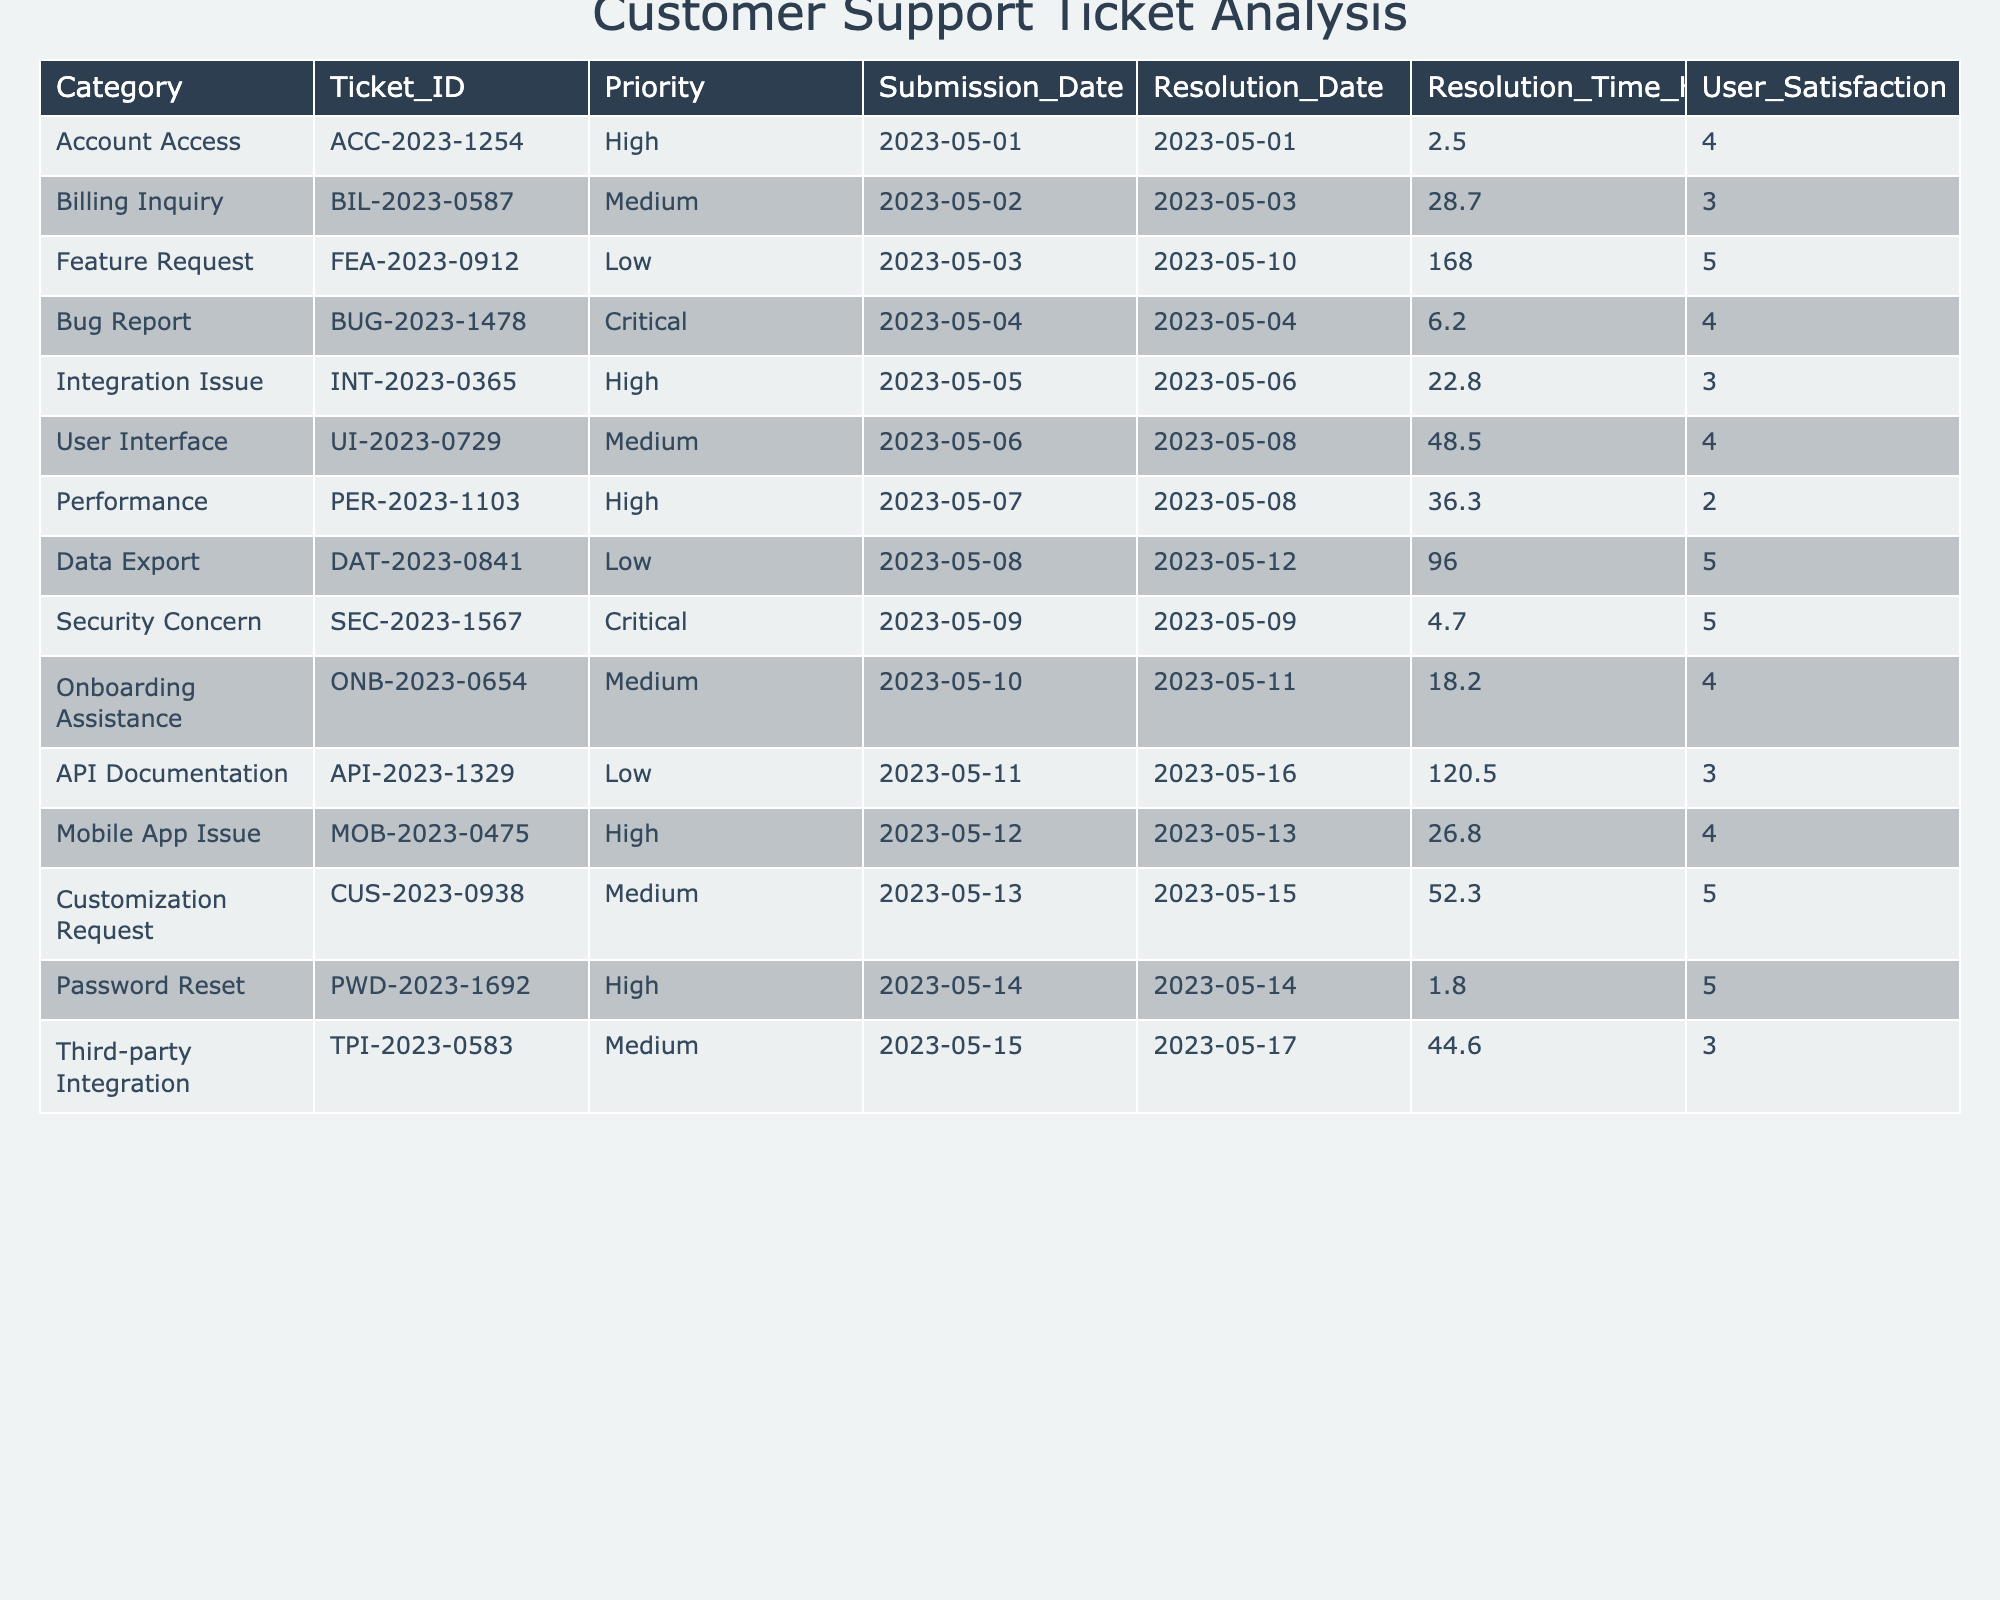What is the average resolution time for all ticket categories? By adding all the resolution times together (2.5 + 28.7 + 168.0 + 6.2 + 22.8 + 48.5 + 36.3 + 96.0 + 4.7 + 18.2 + 120.5 + 26.8 + 52.3 + 1.8 + 44.6) = 552.1 hours, and since there are 15 tickets, the average is 552.1 / 15 = 36.81 hours.
Answer: 36.81 hours Which ticket category had the highest user satisfaction rating? Looking through the user satisfaction ratings, the categories with a score of 5 are Feature Request, Data Export, Security Concern, Password Reset, and Customization Request. Thus, the highest ratings are '5'.
Answer: 5 Is the average resolution time for high-priority tickets less than that for medium-priority tickets? The high-priority tickets have resolution times of 2.5, 22.8, 36.3, 26.8, and 1.8 hours. The average for high-priority is (2.5 + 22.8 + 36.3 + 26.8 + 1.8) / 5 = 18.24 hours. The medium-priority tickets have resolution times of 28.7, 48.5, 18.2, and 44.6 hours, averaging (28.7 + 48.5 + 18.2 + 44.6) / 4 = 35.0 hours. Since 18.24 is less than 35.0, the statement is true.
Answer: Yes How many tickets were resolved on the same day they were submitted? By reviewing the table, the tickets that have matching submission and resolution dates are: Account Access (2.5), Bug Report (6.2), and Security Concern (4.7). Thus, 3 tickets were resolved on the same day.
Answer: 3 Did the priority level affect the resolution time for any category? To assess this, we can compare average resolution times: High (18.24 hours), Medium (35.0 hours), Low (126.55 hours), and Critical (4.7 hours). As each priority level has different averages, it's clear that priority does affect resolution times.
Answer: Yes What is the total number of tickets categorized as Critical? By inspecting the table, there are two Critical tickets: Bug Report and Security Concern, so the total is 2.
Answer: 2 Which category had the longest resolution time? The longest resolution time is found in the Feature Request category, with a time of 168.0 hours.
Answer: Feature Request If a new ticket was created with a priority of High, what would be the expected range for its resolution time based on existing data? The high-priority tickets vary between 1.8 and 36.3 hours. Thus, the expected range for a new high-priority ticket would be between 1.8 and 36.3 hours.
Answer: 1.8 to 36.3 hours What is the sum of the user satisfaction ratings for all tickets? To find the sum of user satisfaction ratings, we add: (4 + 3 + 5 + 4 + 3 + 4 + 2 + 5 + 5 + 4 + 3 + 4 + 5 + 5 + 3) = 58.
Answer: 58 Are there any tickets categorized as 'Customization Request' that have a resolution time longer than 50 hours? The resolution time for the Customization Request ticket is 52.3 hours, which is indeed longer than 50.
Answer: Yes 